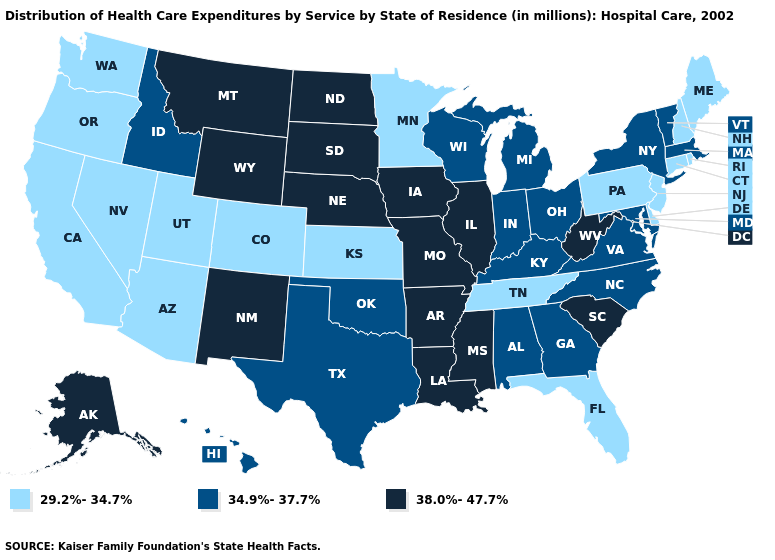Name the states that have a value in the range 34.9%-37.7%?
Concise answer only. Alabama, Georgia, Hawaii, Idaho, Indiana, Kentucky, Maryland, Massachusetts, Michigan, New York, North Carolina, Ohio, Oklahoma, Texas, Vermont, Virginia, Wisconsin. Name the states that have a value in the range 29.2%-34.7%?
Quick response, please. Arizona, California, Colorado, Connecticut, Delaware, Florida, Kansas, Maine, Minnesota, Nevada, New Hampshire, New Jersey, Oregon, Pennsylvania, Rhode Island, Tennessee, Utah, Washington. Does the first symbol in the legend represent the smallest category?
Give a very brief answer. Yes. Name the states that have a value in the range 29.2%-34.7%?
Quick response, please. Arizona, California, Colorado, Connecticut, Delaware, Florida, Kansas, Maine, Minnesota, Nevada, New Hampshire, New Jersey, Oregon, Pennsylvania, Rhode Island, Tennessee, Utah, Washington. Which states have the lowest value in the USA?
Keep it brief. Arizona, California, Colorado, Connecticut, Delaware, Florida, Kansas, Maine, Minnesota, Nevada, New Hampshire, New Jersey, Oregon, Pennsylvania, Rhode Island, Tennessee, Utah, Washington. Name the states that have a value in the range 38.0%-47.7%?
Quick response, please. Alaska, Arkansas, Illinois, Iowa, Louisiana, Mississippi, Missouri, Montana, Nebraska, New Mexico, North Dakota, South Carolina, South Dakota, West Virginia, Wyoming. What is the lowest value in states that border Louisiana?
Quick response, please. 34.9%-37.7%. Name the states that have a value in the range 34.9%-37.7%?
Quick response, please. Alabama, Georgia, Hawaii, Idaho, Indiana, Kentucky, Maryland, Massachusetts, Michigan, New York, North Carolina, Ohio, Oklahoma, Texas, Vermont, Virginia, Wisconsin. Which states have the highest value in the USA?
Give a very brief answer. Alaska, Arkansas, Illinois, Iowa, Louisiana, Mississippi, Missouri, Montana, Nebraska, New Mexico, North Dakota, South Carolina, South Dakota, West Virginia, Wyoming. What is the value of Texas?
Answer briefly. 34.9%-37.7%. What is the value of Kentucky?
Give a very brief answer. 34.9%-37.7%. Name the states that have a value in the range 29.2%-34.7%?
Answer briefly. Arizona, California, Colorado, Connecticut, Delaware, Florida, Kansas, Maine, Minnesota, Nevada, New Hampshire, New Jersey, Oregon, Pennsylvania, Rhode Island, Tennessee, Utah, Washington. Which states have the highest value in the USA?
Write a very short answer. Alaska, Arkansas, Illinois, Iowa, Louisiana, Mississippi, Missouri, Montana, Nebraska, New Mexico, North Dakota, South Carolina, South Dakota, West Virginia, Wyoming. Name the states that have a value in the range 38.0%-47.7%?
Write a very short answer. Alaska, Arkansas, Illinois, Iowa, Louisiana, Mississippi, Missouri, Montana, Nebraska, New Mexico, North Dakota, South Carolina, South Dakota, West Virginia, Wyoming. Name the states that have a value in the range 38.0%-47.7%?
Short answer required. Alaska, Arkansas, Illinois, Iowa, Louisiana, Mississippi, Missouri, Montana, Nebraska, New Mexico, North Dakota, South Carolina, South Dakota, West Virginia, Wyoming. 